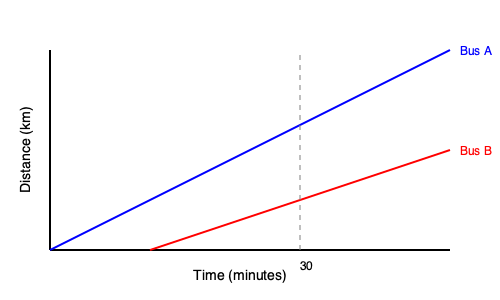Given the time-distance diagram for two bus routes in Bern, Bus A and Bus B, determine the optimal time interval between their departures to minimize waiting time for passengers transferring from Bus A to Bus B at the intersection point. Assume both buses maintain constant speeds throughout their routes. To solve this optimization problem, we need to follow these steps:

1. Understand the diagram:
   - The x-axis represents time in minutes, and the y-axis represents distance in kilometers.
   - The blue line represents Bus A's route, and the red line represents Bus B's route.
   - The intersection point of the two lines is where passengers can transfer between buses.

2. Find the intersection point:
   - The buses intersect at approximately 30 minutes on the x-axis (time).

3. Calculate the speeds of both buses:
   - Bus A: Travels the entire distance (y-axis) in about 40 minutes
   - Bus B: Starts 10 minutes later and travels 2/3 of the distance in 30 minutes

4. Determine the optimal time interval:
   - For minimum waiting time, Bus B should pass through the intersection point just after Bus A arrives.
   - The optimal time interval is the difference between their departure times that allows this to happen.

5. Calculate the optimal interval:
   - Bus A reaches the intersection at 30 minutes.
   - Bus B needs to start later to reach the intersection at slightly after 30 minutes.
   - The optimal interval is approximately 10 minutes (the initial delay of Bus B in the diagram).

This 10-minute interval ensures that passengers from Bus A can transfer to Bus B with minimal waiting time at the intersection point.
Answer: 10 minutes 